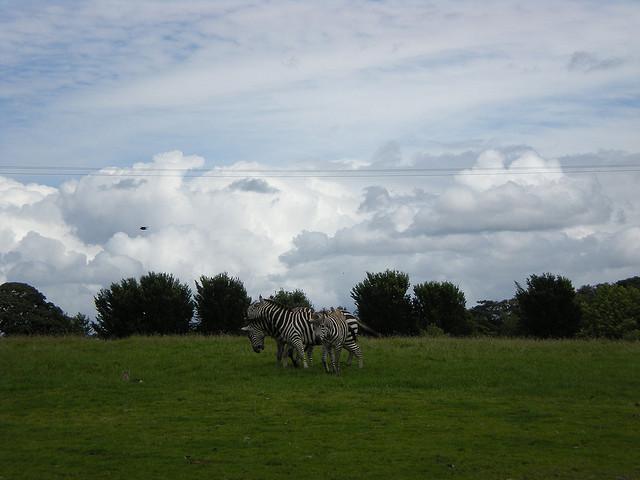How many zebras are babies?
Give a very brief answer. 1. How many dry patches are in the grass?
Give a very brief answer. 0. How many people are there?
Give a very brief answer. 0. How many zebras are in the picture?
Give a very brief answer. 3. 